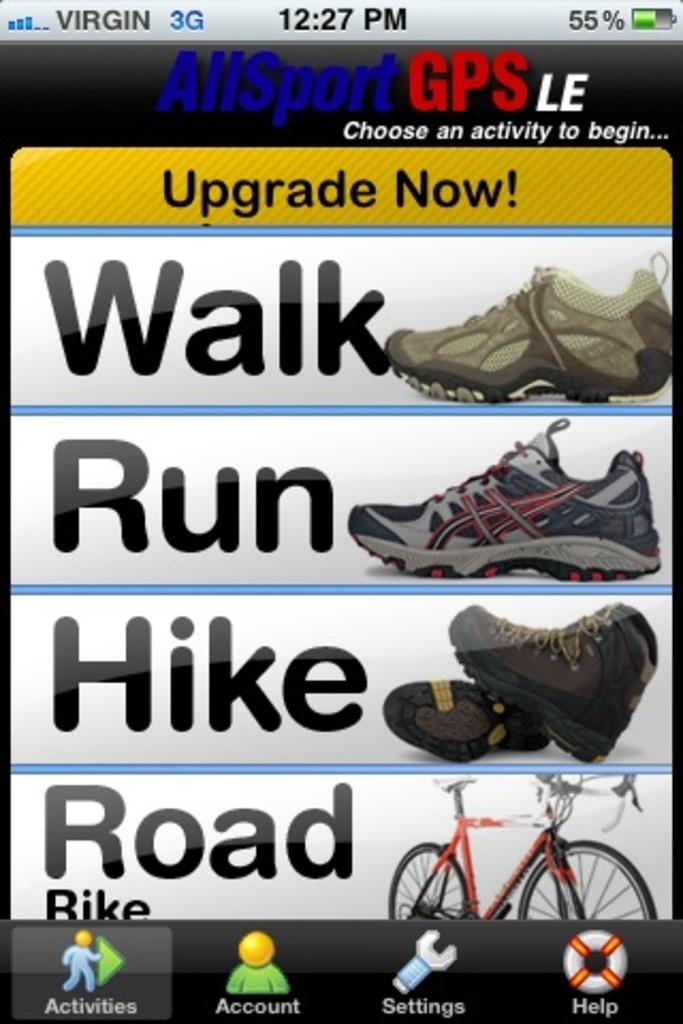What type of footwear is visible in the image? There are shoes in the image. What mode of transportation can be seen in the image? There is a bicycle in the image. What type of verse is being recited by the snake in the image? There is no snake or verse present in the image. How does the bicycle say good-bye to the shoes in the image? The bicycle is an inanimate object and does not have the ability to say good-bye. 